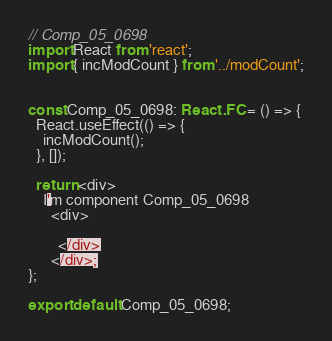Convert code to text. <code><loc_0><loc_0><loc_500><loc_500><_TypeScript_>// Comp_05_0698
import React from 'react';
import { incModCount } from '../modCount';


const Comp_05_0698: React.FC = () => {
  React.useEffect(() => {
    incModCount();
  }, []);

  return <div>
    I'm component Comp_05_0698
      <div>
      
        </div>
      </div>;
};

export default Comp_05_0698;
</code> 